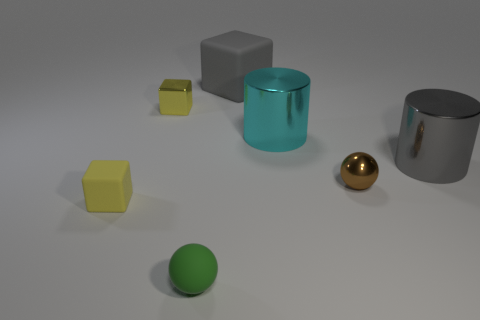Is there anything else that is the same color as the metallic ball?
Offer a very short reply. No. There is another yellow object that is the same shape as the small yellow metal object; what is its material?
Your answer should be compact. Rubber. Are the cylinder that is to the right of the shiny ball and the sphere behind the tiny green ball made of the same material?
Keep it short and to the point. Yes. There is a sphere behind the sphere to the left of the ball behind the tiny green ball; what color is it?
Provide a short and direct response. Brown. What number of other things are the same shape as the small brown shiny object?
Make the answer very short. 1. Is the metal cube the same color as the small matte cube?
Offer a very short reply. Yes. What number of objects are tiny yellow blocks or metal objects behind the brown thing?
Your answer should be very brief. 4. Are there any gray cubes of the same size as the cyan shiny cylinder?
Your answer should be very brief. Yes. Are the brown thing and the large gray cylinder made of the same material?
Give a very brief answer. Yes. How many things are tiny yellow metallic blocks or spheres?
Offer a terse response. 3. 